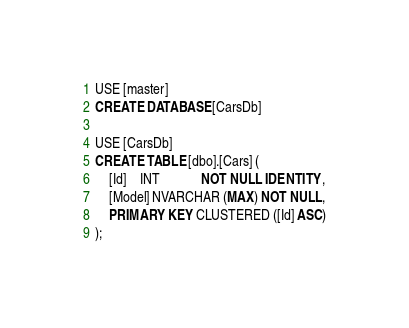Convert code to text. <code><loc_0><loc_0><loc_500><loc_500><_SQL_>USE [master]
CREATE DATABASE [CarsDb]

USE [CarsDb]
CREATE TABLE [dbo].[Cars] (
    [Id]    INT            NOT NULL IDENTITY,
    [Model] NVARCHAR (MAX) NOT NULL,
    PRIMARY KEY CLUSTERED ([Id] ASC)
);</code> 